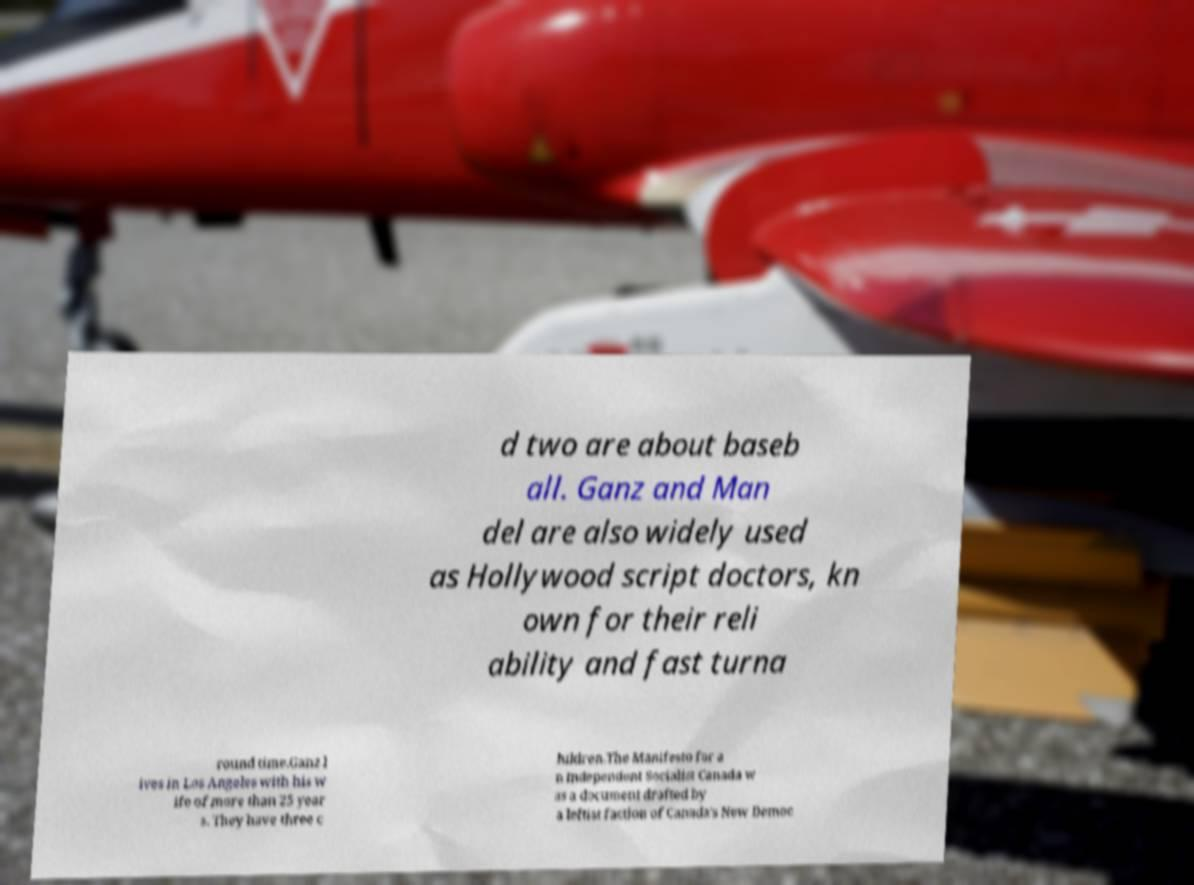I need the written content from this picture converted into text. Can you do that? d two are about baseb all. Ganz and Man del are also widely used as Hollywood script doctors, kn own for their reli ability and fast turna round time.Ganz l ives in Los Angeles with his w ife of more than 25 year s. They have three c hildren.The Manifesto for a n Independent Socialist Canada w as a document drafted by a leftist faction of Canada's New Democ 